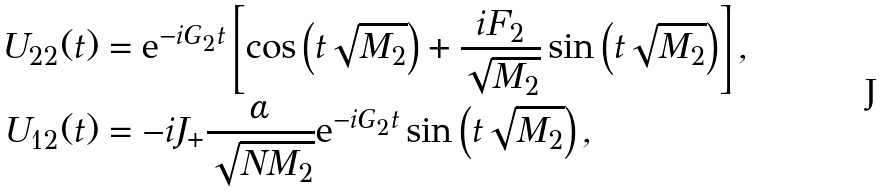Convert formula to latex. <formula><loc_0><loc_0><loc_500><loc_500>U _ { 2 2 } ( t ) & = \mathrm e ^ { - i G _ { 2 } t } \left [ \cos \left ( t \sqrt { M _ { 2 } } \right ) + \frac { i F _ { 2 } } { \sqrt { M _ { 2 } } } \sin \left ( t \sqrt { M _ { 2 } } \right ) \right ] , \\ U _ { 1 2 } ( t ) & = - i J _ { + } \frac { \alpha } { \sqrt { N M _ { 2 } } } \mathrm e ^ { - i G _ { 2 } t } \sin \left ( t \sqrt { M _ { 2 } } \right ) ,</formula> 